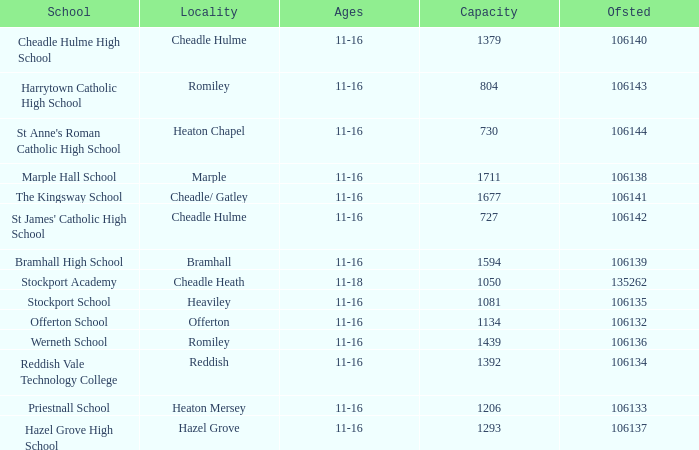What is heaton chapel's capacity? 730.0. Give me the full table as a dictionary. {'header': ['School', 'Locality', 'Ages', 'Capacity', 'Ofsted'], 'rows': [['Cheadle Hulme High School', 'Cheadle Hulme', '11-16', '1379', '106140'], ['Harrytown Catholic High School', 'Romiley', '11-16', '804', '106143'], ["St Anne's Roman Catholic High School", 'Heaton Chapel', '11-16', '730', '106144'], ['Marple Hall School', 'Marple', '11-16', '1711', '106138'], ['The Kingsway School', 'Cheadle/ Gatley', '11-16', '1677', '106141'], ["St James' Catholic High School", 'Cheadle Hulme', '11-16', '727', '106142'], ['Bramhall High School', 'Bramhall', '11-16', '1594', '106139'], ['Stockport Academy', 'Cheadle Heath', '11-18', '1050', '135262'], ['Stockport School', 'Heaviley', '11-16', '1081', '106135'], ['Offerton School', 'Offerton', '11-16', '1134', '106132'], ['Werneth School', 'Romiley', '11-16', '1439', '106136'], ['Reddish Vale Technology College', 'Reddish', '11-16', '1392', '106134'], ['Priestnall School', 'Heaton Mersey', '11-16', '1206', '106133'], ['Hazel Grove High School', 'Hazel Grove', '11-16', '1293', '106137']]} 